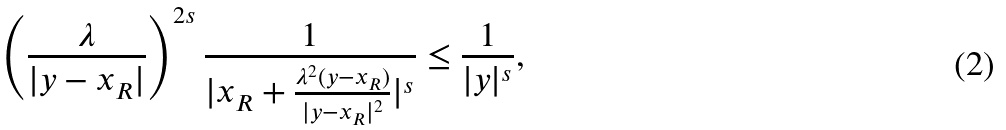<formula> <loc_0><loc_0><loc_500><loc_500>\left ( \frac { \lambda } { | y - x _ { R } | } \right ) ^ { 2 s } \frac { 1 } { | x _ { R } + \frac { \lambda ^ { 2 } ( y - x _ { R } ) } { | y - x _ { R } | ^ { 2 } } | ^ { s } } \leq \frac { 1 } { | y | ^ { s } } ,</formula> 